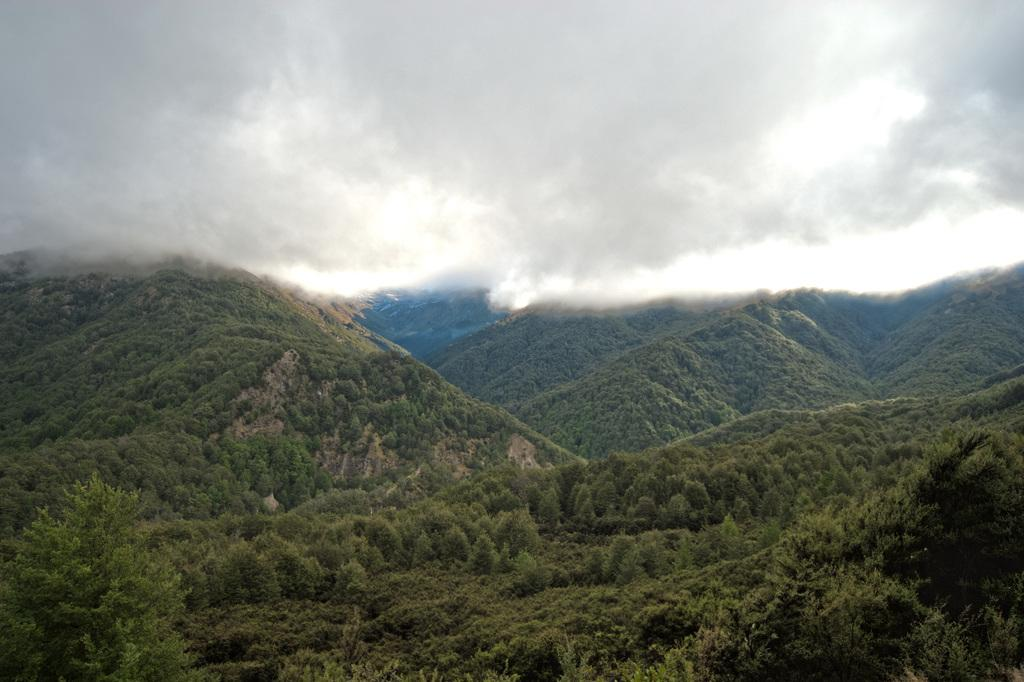What type of location is depicted in the image? The image is an outside view. What natural features can be seen in the image? There are many trees and mountains in the image. What is visible at the top of the image? The sky is visible at the top of the image. What is the weather like in the image? The sky is cloudy in the image. What shape is the yam in the image? There is no yam present in the image. How many sides does the square have in the image? There is no square present in the image. 